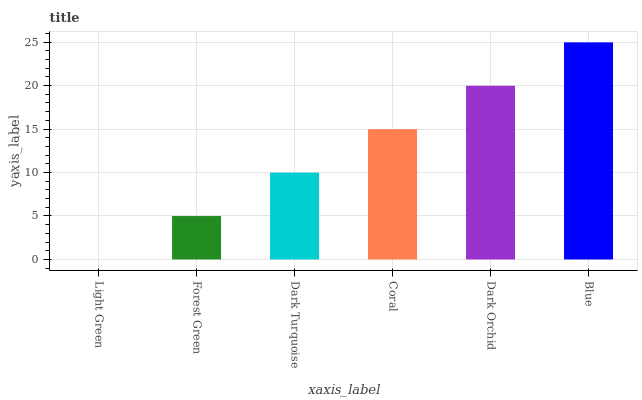Is Light Green the minimum?
Answer yes or no. Yes. Is Blue the maximum?
Answer yes or no. Yes. Is Forest Green the minimum?
Answer yes or no. No. Is Forest Green the maximum?
Answer yes or no. No. Is Forest Green greater than Light Green?
Answer yes or no. Yes. Is Light Green less than Forest Green?
Answer yes or no. Yes. Is Light Green greater than Forest Green?
Answer yes or no. No. Is Forest Green less than Light Green?
Answer yes or no. No. Is Coral the high median?
Answer yes or no. Yes. Is Dark Turquoise the low median?
Answer yes or no. Yes. Is Forest Green the high median?
Answer yes or no. No. Is Coral the low median?
Answer yes or no. No. 